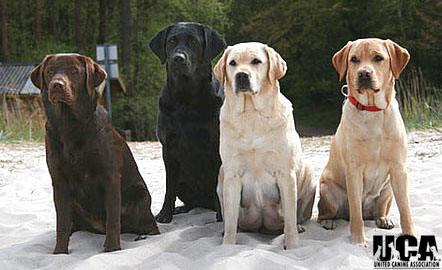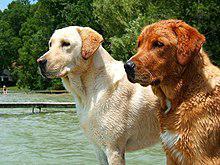The first image is the image on the left, the second image is the image on the right. Assess this claim about the two images: "The image on the right has three dogs that are all sitting.". Correct or not? Answer yes or no. No. The first image is the image on the left, the second image is the image on the right. For the images shown, is this caption "labs are sitting near a river" true? Answer yes or no. Yes. 